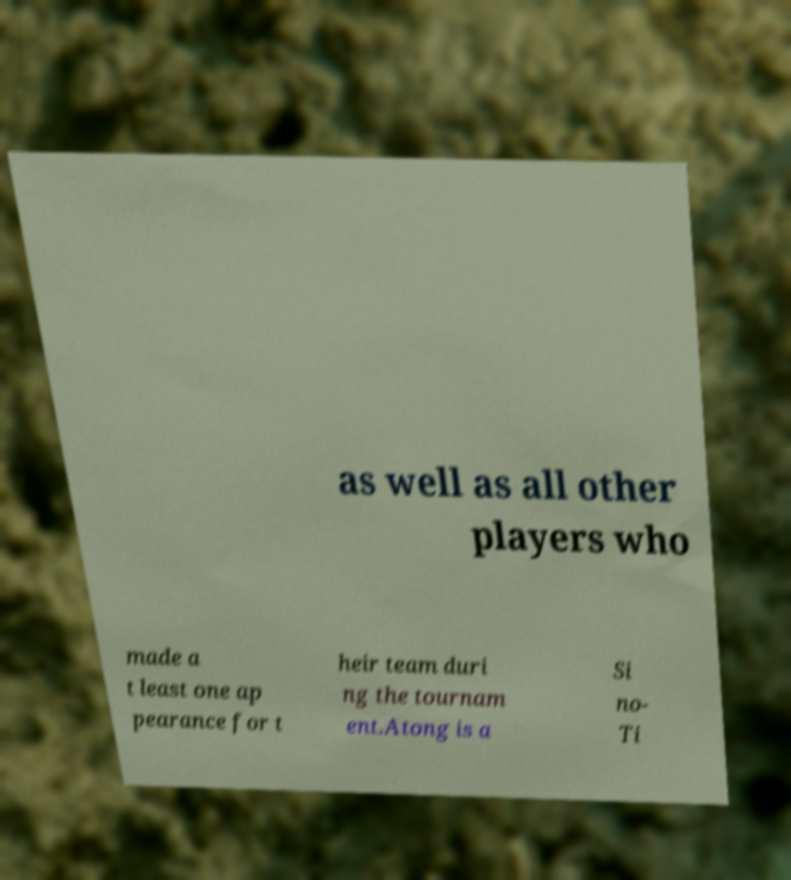I need the written content from this picture converted into text. Can you do that? as well as all other players who made a t least one ap pearance for t heir team duri ng the tournam ent.Atong is a Si no- Ti 